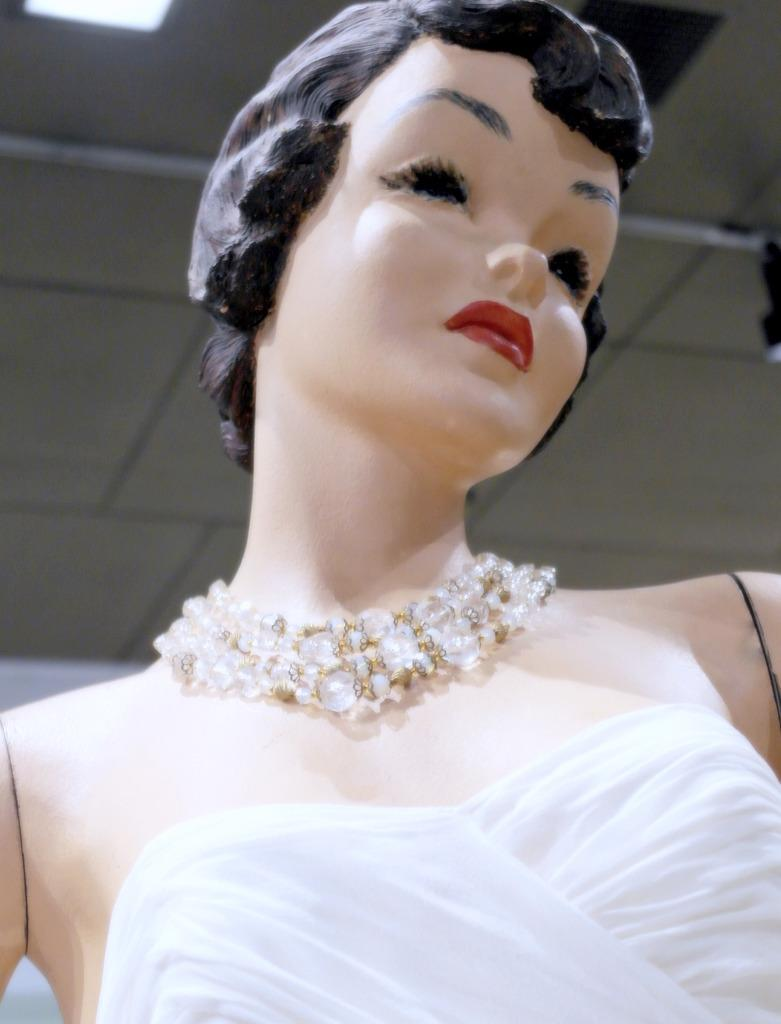What is the main subject of the image? There is a mannequin in the image. What is the mannequin wearing? The mannequin is wearing a white dress. Are there any accessories on the mannequin? Yes, the mannequin has jewelry. What can be seen in the background of the image? There is a roof visible in the background of the image. Reasoning: Let's think step by following the guidelines to produce the conversation. We start by identifying the main subject of the image, which is the mannequin. Then, we describe the clothing and accessories of the mannequin based on the provided facts. Finally, we mention the background element, which is the roof. Each question is designed to elicit a specific detail about the image that is known from the provided facts. Absurd Question/Answer: How does the tax affect the river in the image? There is no river or tax mentioned in the image; it only features a mannequin wearing a white dress and jewelry, with a roof visible in the background. 